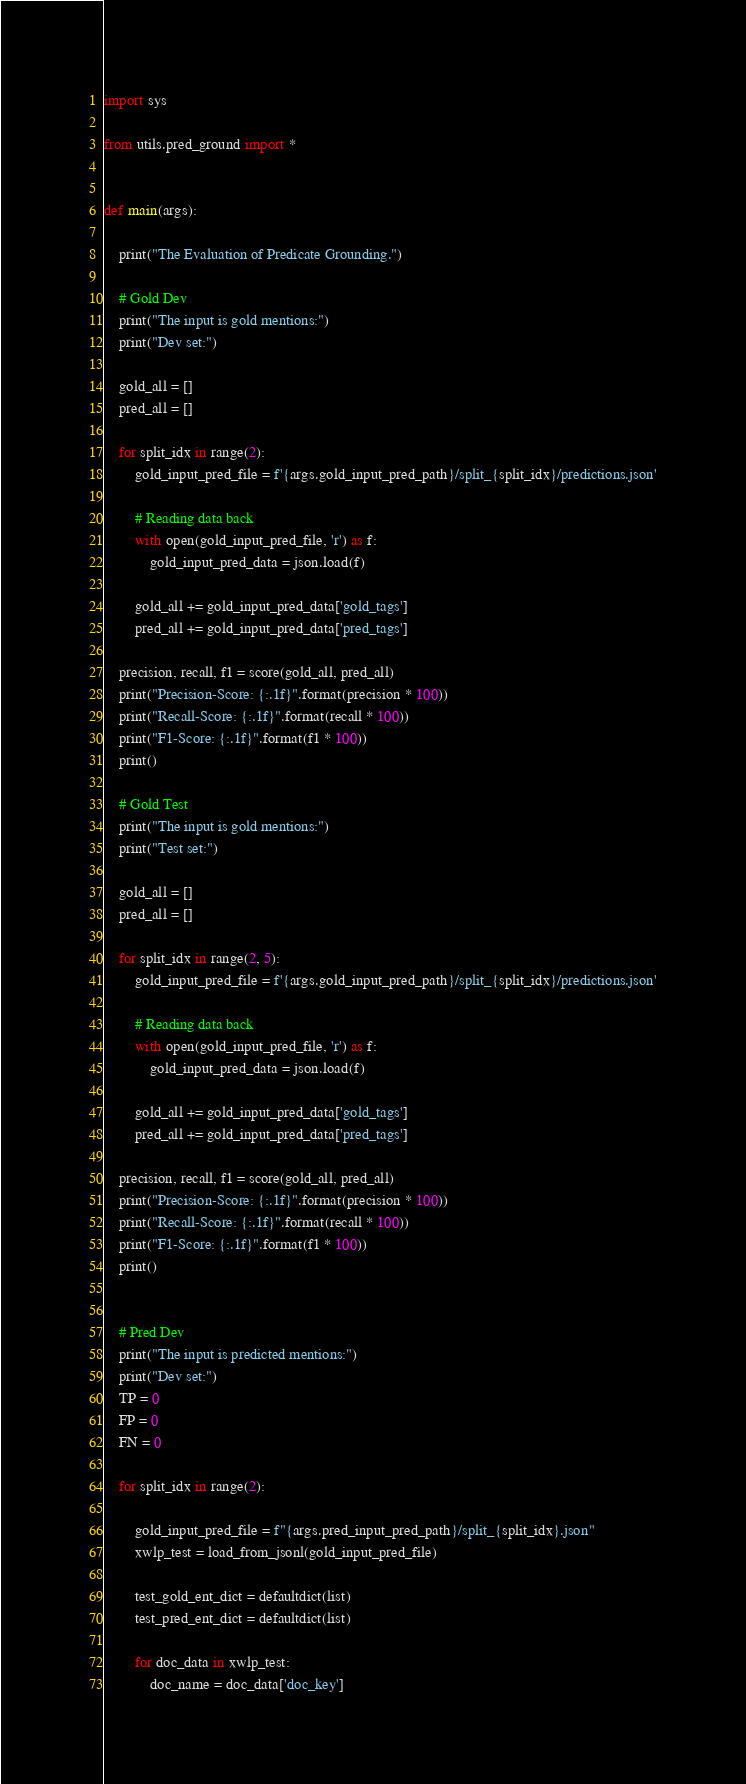<code> <loc_0><loc_0><loc_500><loc_500><_Python_>
import sys

from utils.pred_ground import *


def main(args):

    print("The Evaluation of Predicate Grounding.")

    # Gold Dev
    print("The input is gold mentions:")
    print("Dev set:")

    gold_all = []
    pred_all = []

    for split_idx in range(2):
        gold_input_pred_file = f'{args.gold_input_pred_path}/split_{split_idx}/predictions.json'

        # Reading data back
        with open(gold_input_pred_file, 'r') as f:
            gold_input_pred_data = json.load(f)

        gold_all += gold_input_pred_data['gold_tags']
        pred_all += gold_input_pred_data['pred_tags']

    precision, recall, f1 = score(gold_all, pred_all)
    print("Precision-Score: {:.1f}".format(precision * 100))
    print("Recall-Score: {:.1f}".format(recall * 100))
    print("F1-Score: {:.1f}".format(f1 * 100))
    print()

    # Gold Test
    print("The input is gold mentions:")
    print("Test set:")

    gold_all = []
    pred_all = []

    for split_idx in range(2, 5):
        gold_input_pred_file = f'{args.gold_input_pred_path}/split_{split_idx}/predictions.json'

        # Reading data back
        with open(gold_input_pred_file, 'r') as f:
            gold_input_pred_data = json.load(f)

        gold_all += gold_input_pred_data['gold_tags']
        pred_all += gold_input_pred_data['pred_tags']

    precision, recall, f1 = score(gold_all, pred_all)
    print("Precision-Score: {:.1f}".format(precision * 100))
    print("Recall-Score: {:.1f}".format(recall * 100))
    print("F1-Score: {:.1f}".format(f1 * 100))
    print()


    # Pred Dev
    print("The input is predicted mentions:")
    print("Dev set:")
    TP = 0
    FP = 0
    FN = 0

    for split_idx in range(2):

        gold_input_pred_file = f"{args.pred_input_pred_path}/split_{split_idx}.json"
        xwlp_test = load_from_jsonl(gold_input_pred_file)

        test_gold_ent_dict = defaultdict(list)
        test_pred_ent_dict = defaultdict(list)

        for doc_data in xwlp_test:
            doc_name = doc_data['doc_key']</code> 